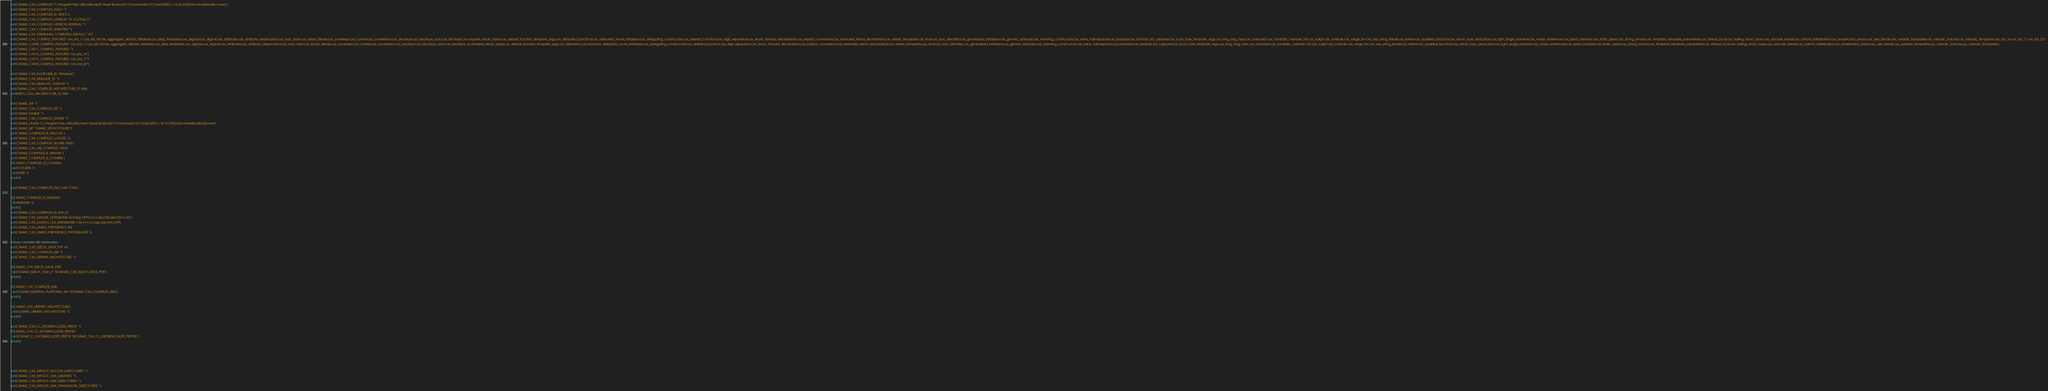Convert code to text. <code><loc_0><loc_0><loc_500><loc_500><_CMake_>set(CMAKE_CXX_COMPILER "C:/Program Files (x86)/Microsoft Visual Studio/2017/Community/VC/Tools/MSVC/14.16.27023/bin/Hostx86/x86/cl.exe")
set(CMAKE_CXX_COMPILER_ARG1 "")
set(CMAKE_CXX_COMPILER_ID "MSVC")
set(CMAKE_CXX_COMPILER_VERSION "19.16.27024.1")
set(CMAKE_CXX_COMPILER_VERSION_INTERNAL "")
set(CMAKE_CXX_COMPILER_WRAPPER "")
set(CMAKE_CXX_STANDARD_COMPUTED_DEFAULT "14")
set(CMAKE_CXX_COMPILE_FEATURES "cxx_std_11;cxx_std_98;cxx_aggregate_default_initializers;cxx_alias_templates;cxx_alignas;cxx_alignof;cxx_attributes;cxx_attribute_deprecated;cxx_auto_type;cxx_binary_literals;cxx_constexpr;cxx_contextual_conversions;cxx_decltype;cxx_decltype_auto;cxx_decltype_incomplete_return_types;cxx_default_function_template_args;cxx_defaulted_functions;cxx_defaulted_move_initializers;cxx_delegating_constructors;cxx_deleted_functions;cxx_digit_separators;cxx_enum_forward_declarations;cxx_explicit_conversions;cxx_extended_friend_declarations;cxx_extern_templates;cxx_final;cxx_func_identifier;cxx_generalized_initializers;cxx_generic_lambdas;cxx_inheriting_constructors;cxx_inline_namespaces;cxx_lambdas;cxx_lambda_init_captures;cxx_local_type_template_args;cxx_long_long_type;cxx_noexcept;cxx_nonstatic_member_init;cxx_nullptr;cxx_override;cxx_range_for;cxx_raw_string_literals;cxx_reference_qualified_functions;cxx_return_type_deduction;cxx_right_angle_brackets;cxx_rvalue_references;cxx_sizeof_member;cxx_static_assert;cxx_strong_enums;cxx_template_template_parameters;cxx_thread_local;cxx_trailing_return_types;cxx_unicode_literals;cxx_uniform_initialization;cxx_unrestricted_unions;cxx_user_literals;cxx_variable_templates;cxx_variadic_macros;cxx_variadic_templates;cxx_std_14;cxx_std_17;cxx_std_20")
set(CMAKE_CXX98_COMPILE_FEATURES "cxx_std_11;cxx_std_98;cxx_aggregate_default_initializers;cxx_alias_templates;cxx_alignas;cxx_alignof;cxx_attributes;cxx_attribute_deprecated;cxx_auto_type;cxx_binary_literals;cxx_constexpr;cxx_contextual_conversions;cxx_decltype;cxx_decltype_auto;cxx_decltype_incomplete_return_types;cxx_default_function_template_args;cxx_defaulted_functions;cxx_defaulted_move_initializers;cxx_delegating_constructors;cxx_deleted_functions;cxx_digit_separators;cxx_enum_forward_declarations;cxx_explicit_conversions;cxx_extended_friend_declarations;cxx_extern_templates;cxx_final;cxx_func_identifier;cxx_generalized_initializers;cxx_generic_lambdas;cxx_inheriting_constructors;cxx_inline_namespaces;cxx_lambdas;cxx_lambda_init_captures;cxx_local_type_template_args;cxx_long_long_type;cxx_noexcept;cxx_nonstatic_member_init;cxx_nullptr;cxx_override;cxx_range_for;cxx_raw_string_literals;cxx_reference_qualified_functions;cxx_return_type_deduction;cxx_right_angle_brackets;cxx_rvalue_references;cxx_sizeof_member;cxx_static_assert;cxx_strong_enums;cxx_template_template_parameters;cxx_thread_local;cxx_trailing_return_types;cxx_unicode_literals;cxx_uniform_initialization;cxx_unrestricted_unions;cxx_user_literals;cxx_variable_templates;cxx_variadic_macros;cxx_variadic_templates")
set(CMAKE_CXX11_COMPILE_FEATURES "")
set(CMAKE_CXX14_COMPILE_FEATURES "cxx_std_14")
set(CMAKE_CXX17_COMPILE_FEATURES "cxx_std_17")
set(CMAKE_CXX20_COMPILE_FEATURES "cxx_std_20")

set(CMAKE_CXX_PLATFORM_ID "Windows")
set(CMAKE_CXX_SIMULATE_ID "")
set(CMAKE_CXX_SIMULATE_VERSION "")
set(CMAKE_CXX_COMPILER_ARCHITECTURE_ID X86)
set(MSVC_CXX_ARCHITECTURE_ID X86)

set(CMAKE_AR "")
set(CMAKE_CXX_COMPILER_AR "")
set(CMAKE_RANLIB "")
set(CMAKE_CXX_COMPILER_RANLIB "")
set(CMAKE_LINKER "C:/Program Files (x86)/Microsoft Visual Studio/2017/Community/VC/Tools/MSVC/14.16.27023/bin/Hostx86/x86/link.exe")
set(CMAKE_MT "CMAKE_MT-NOTFOUND")
set(CMAKE_COMPILER_IS_GNUCXX )
set(CMAKE_CXX_COMPILER_LOADED 1)
set(CMAKE_CXX_COMPILER_WORKS TRUE)
set(CMAKE_CXX_ABI_COMPILED TRUE)
set(CMAKE_COMPILER_IS_MINGW )
set(CMAKE_COMPILER_IS_CYGWIN )
if(CMAKE_COMPILER_IS_CYGWIN)
  set(CYGWIN 1)
  set(UNIX 1)
endif()

set(CMAKE_CXX_COMPILER_ENV_VAR "CXX")

if(CMAKE_COMPILER_IS_MINGW)
  set(MINGW 1)
endif()
set(CMAKE_CXX_COMPILER_ID_RUN 1)
set(CMAKE_CXX_IGNORE_EXTENSIONS inl;h;hpp;HPP;H;o;O;obj;OBJ;def;DEF;rc;RC)
set(CMAKE_CXX_SOURCE_FILE_EXTENSIONS C;M;c++;cc;cpp;cxx;mm;CPP)
set(CMAKE_CXX_LINKER_PREFERENCE 30)
set(CMAKE_CXX_LINKER_PREFERENCE_PROPAGATES 1)

# Save compiler ABI information.
set(CMAKE_CXX_SIZEOF_DATA_PTR "4")
set(CMAKE_CXX_COMPILER_ABI "")
set(CMAKE_CXX_LIBRARY_ARCHITECTURE "")

if(CMAKE_CXX_SIZEOF_DATA_PTR)
  set(CMAKE_SIZEOF_VOID_P "${CMAKE_CXX_SIZEOF_DATA_PTR}")
endif()

if(CMAKE_CXX_COMPILER_ABI)
  set(CMAKE_INTERNAL_PLATFORM_ABI "${CMAKE_CXX_COMPILER_ABI}")
endif()

if(CMAKE_CXX_LIBRARY_ARCHITECTURE)
  set(CMAKE_LIBRARY_ARCHITECTURE "")
endif()

set(CMAKE_CXX_CL_SHOWINCLUDES_PREFIX "")
if(CMAKE_CXX_CL_SHOWINCLUDES_PREFIX)
  set(CMAKE_CL_SHOWINCLUDES_PREFIX "${CMAKE_CXX_CL_SHOWINCLUDES_PREFIX}")
endif()





set(CMAKE_CXX_IMPLICIT_INCLUDE_DIRECTORIES "")
set(CMAKE_CXX_IMPLICIT_LINK_LIBRARIES "")
set(CMAKE_CXX_IMPLICIT_LINK_DIRECTORIES "")
set(CMAKE_CXX_IMPLICIT_LINK_FRAMEWORK_DIRECTORIES "")
</code> 